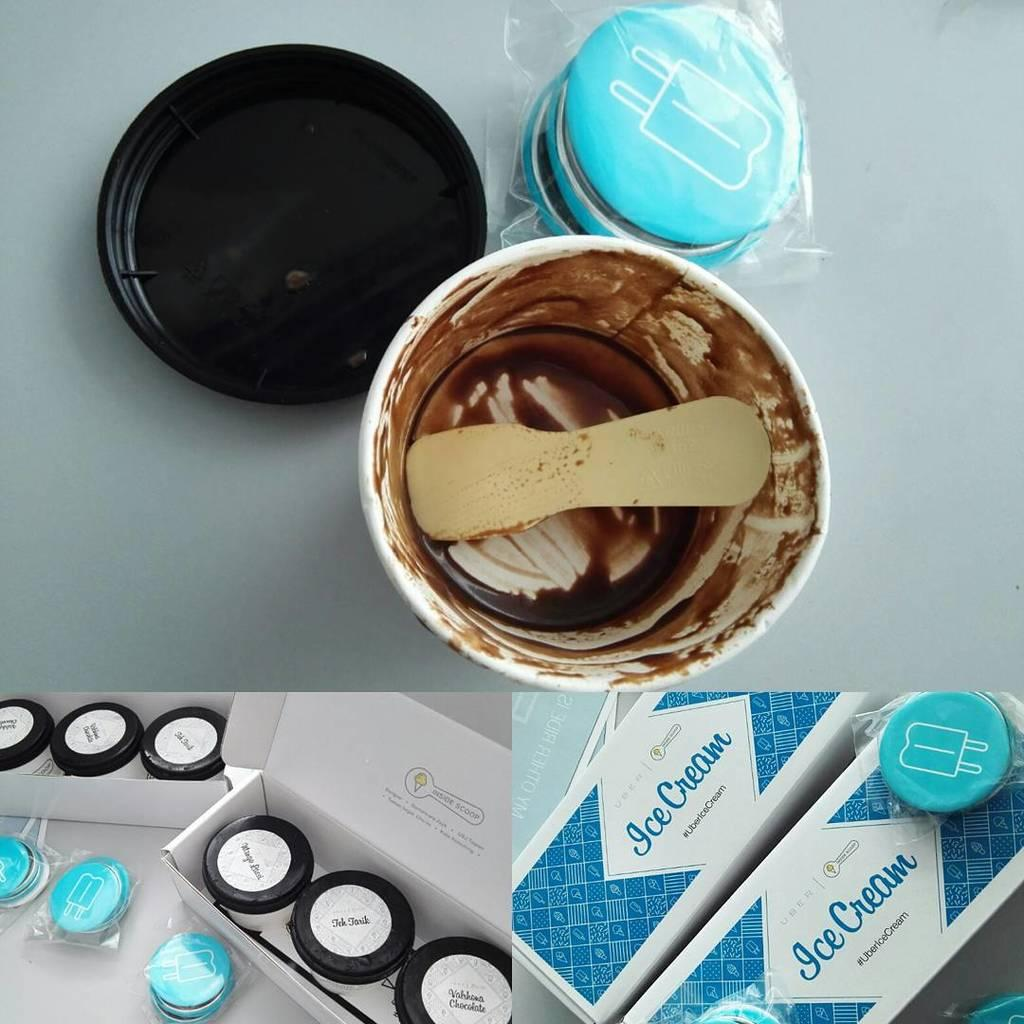<image>
Create a compact narrative representing the image presented. several different scenes of UBER Ice CREAM boxes and containers 